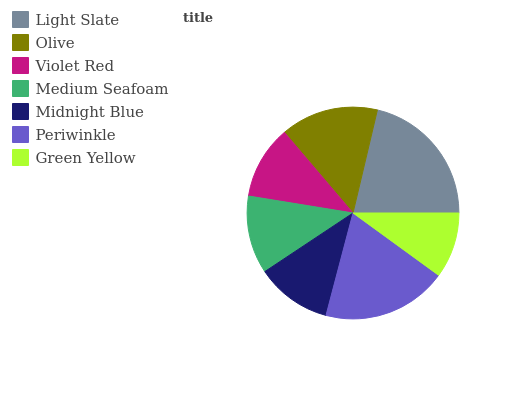Is Green Yellow the minimum?
Answer yes or no. Yes. Is Light Slate the maximum?
Answer yes or no. Yes. Is Olive the minimum?
Answer yes or no. No. Is Olive the maximum?
Answer yes or no. No. Is Light Slate greater than Olive?
Answer yes or no. Yes. Is Olive less than Light Slate?
Answer yes or no. Yes. Is Olive greater than Light Slate?
Answer yes or no. No. Is Light Slate less than Olive?
Answer yes or no. No. Is Medium Seafoam the high median?
Answer yes or no. Yes. Is Medium Seafoam the low median?
Answer yes or no. Yes. Is Light Slate the high median?
Answer yes or no. No. Is Midnight Blue the low median?
Answer yes or no. No. 